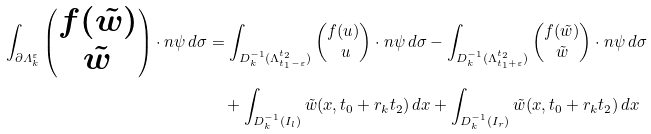Convert formula to latex. <formula><loc_0><loc_0><loc_500><loc_500>\int _ { \partial \varLambda ^ { \varepsilon } _ { k } } \begin{pmatrix} f ( \tilde { w } ) \\ \tilde { w } \end{pmatrix} \cdot n \psi \, d \sigma & = \int _ { D _ { k } ^ { - 1 } ( \Lambda _ { t _ { 1 } - \varepsilon } ^ { t _ { 2 } } ) } \begin{pmatrix} f ( u ) \\ \ u \end{pmatrix} \cdot n \psi \, d \sigma - \int _ { D _ { k } ^ { - 1 } ( \Lambda _ { t _ { 1 } + \varepsilon } ^ { t _ { 2 } } ) } \begin{pmatrix} f ( \tilde { w } ) \\ \tilde { w } \end{pmatrix} \cdot n \psi \, d \sigma \\ & \quad + \int _ { D _ { k } ^ { - 1 } ( I _ { l } ) } \tilde { w } ( x , t _ { 0 } + r _ { k } t _ { 2 } ) \, d x + \int _ { D _ { k } ^ { - 1 } ( I _ { r } ) } \tilde { w } ( x , t _ { 0 } + r _ { k } t _ { 2 } ) \, d x</formula> 